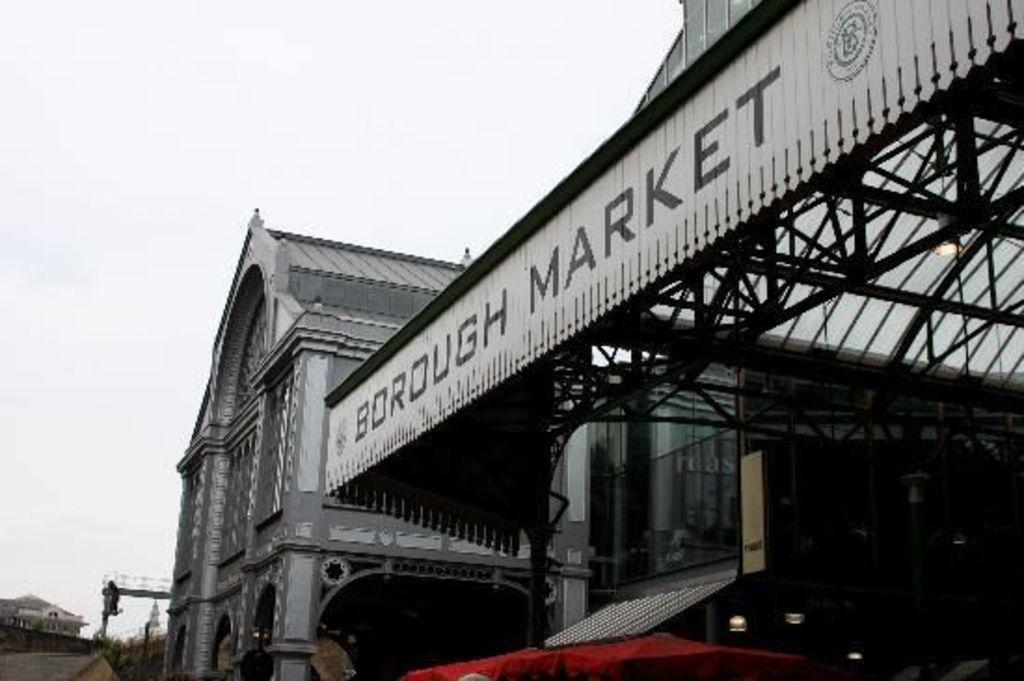What type of structure is present in the image? There is a building in the image. What part of the natural environment can be seen in the image? The sky is visible at the top of the building in the image. Can you see a list of items hanging from a hook in the image? There is no list or hook present in the image. 